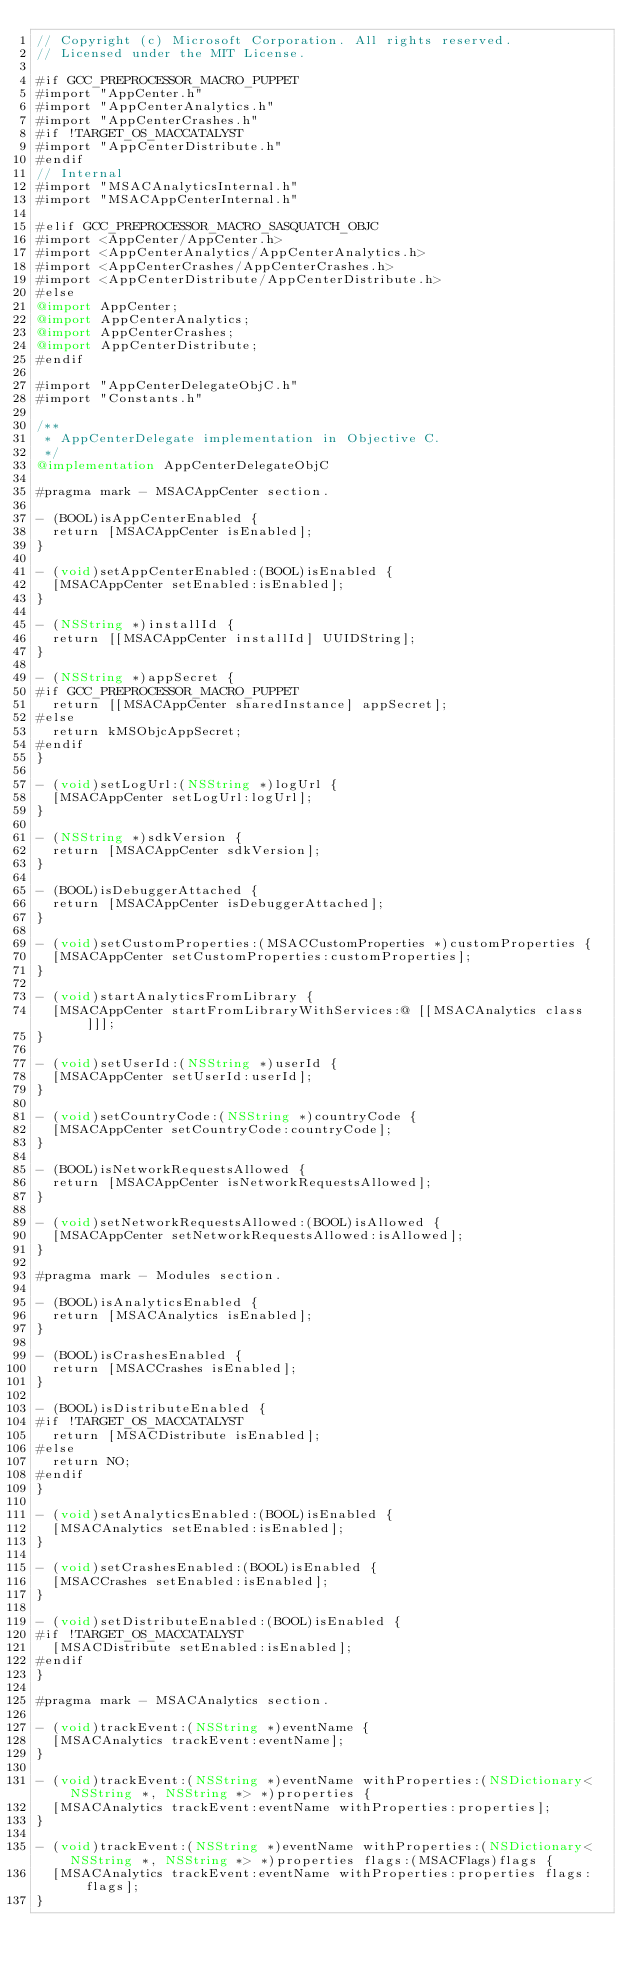Convert code to text. <code><loc_0><loc_0><loc_500><loc_500><_ObjectiveC_>// Copyright (c) Microsoft Corporation. All rights reserved.
// Licensed under the MIT License.

#if GCC_PREPROCESSOR_MACRO_PUPPET
#import "AppCenter.h"
#import "AppCenterAnalytics.h"
#import "AppCenterCrashes.h"
#if !TARGET_OS_MACCATALYST
#import "AppCenterDistribute.h"
#endif
// Internal
#import "MSACAnalyticsInternal.h"
#import "MSACAppCenterInternal.h"

#elif GCC_PREPROCESSOR_MACRO_SASQUATCH_OBJC
#import <AppCenter/AppCenter.h>
#import <AppCenterAnalytics/AppCenterAnalytics.h>
#import <AppCenterCrashes/AppCenterCrashes.h>
#import <AppCenterDistribute/AppCenterDistribute.h>
#else
@import AppCenter;
@import AppCenterAnalytics;
@import AppCenterCrashes;
@import AppCenterDistribute;
#endif

#import "AppCenterDelegateObjC.h"
#import "Constants.h"

/**
 * AppCenterDelegate implementation in Objective C.
 */
@implementation AppCenterDelegateObjC

#pragma mark - MSACAppCenter section.

- (BOOL)isAppCenterEnabled {
  return [MSACAppCenter isEnabled];
}

- (void)setAppCenterEnabled:(BOOL)isEnabled {
  [MSACAppCenter setEnabled:isEnabled];
}

- (NSString *)installId {
  return [[MSACAppCenter installId] UUIDString];
}

- (NSString *)appSecret {
#if GCC_PREPROCESSOR_MACRO_PUPPET
  return [[MSACAppCenter sharedInstance] appSecret];
#else
  return kMSObjcAppSecret;
#endif
}

- (void)setLogUrl:(NSString *)logUrl {
  [MSACAppCenter setLogUrl:logUrl];
}

- (NSString *)sdkVersion {
  return [MSACAppCenter sdkVersion];
}

- (BOOL)isDebuggerAttached {
  return [MSACAppCenter isDebuggerAttached];
}

- (void)setCustomProperties:(MSACCustomProperties *)customProperties {
  [MSACAppCenter setCustomProperties:customProperties];
}

- (void)startAnalyticsFromLibrary {
  [MSACAppCenter startFromLibraryWithServices:@ [[MSACAnalytics class]]];
}

- (void)setUserId:(NSString *)userId {
  [MSACAppCenter setUserId:userId];
}

- (void)setCountryCode:(NSString *)countryCode {
  [MSACAppCenter setCountryCode:countryCode];
}

- (BOOL)isNetworkRequestsAllowed {
  return [MSACAppCenter isNetworkRequestsAllowed];
}

- (void)setNetworkRequestsAllowed:(BOOL)isAllowed {
  [MSACAppCenter setNetworkRequestsAllowed:isAllowed];
}

#pragma mark - Modules section.

- (BOOL)isAnalyticsEnabled {
  return [MSACAnalytics isEnabled];
}

- (BOOL)isCrashesEnabled {
  return [MSACCrashes isEnabled];
}

- (BOOL)isDistributeEnabled {
#if !TARGET_OS_MACCATALYST
  return [MSACDistribute isEnabled];
#else
  return NO;
#endif
}

- (void)setAnalyticsEnabled:(BOOL)isEnabled {
  [MSACAnalytics setEnabled:isEnabled];
}

- (void)setCrashesEnabled:(BOOL)isEnabled {
  [MSACCrashes setEnabled:isEnabled];
}

- (void)setDistributeEnabled:(BOOL)isEnabled {
#if !TARGET_OS_MACCATALYST
  [MSACDistribute setEnabled:isEnabled];
#endif
}

#pragma mark - MSACAnalytics section.

- (void)trackEvent:(NSString *)eventName {
  [MSACAnalytics trackEvent:eventName];
}

- (void)trackEvent:(NSString *)eventName withProperties:(NSDictionary<NSString *, NSString *> *)properties {
  [MSACAnalytics trackEvent:eventName withProperties:properties];
}

- (void)trackEvent:(NSString *)eventName withProperties:(NSDictionary<NSString *, NSString *> *)properties flags:(MSACFlags)flags {
  [MSACAnalytics trackEvent:eventName withProperties:properties flags:flags];
}
</code> 